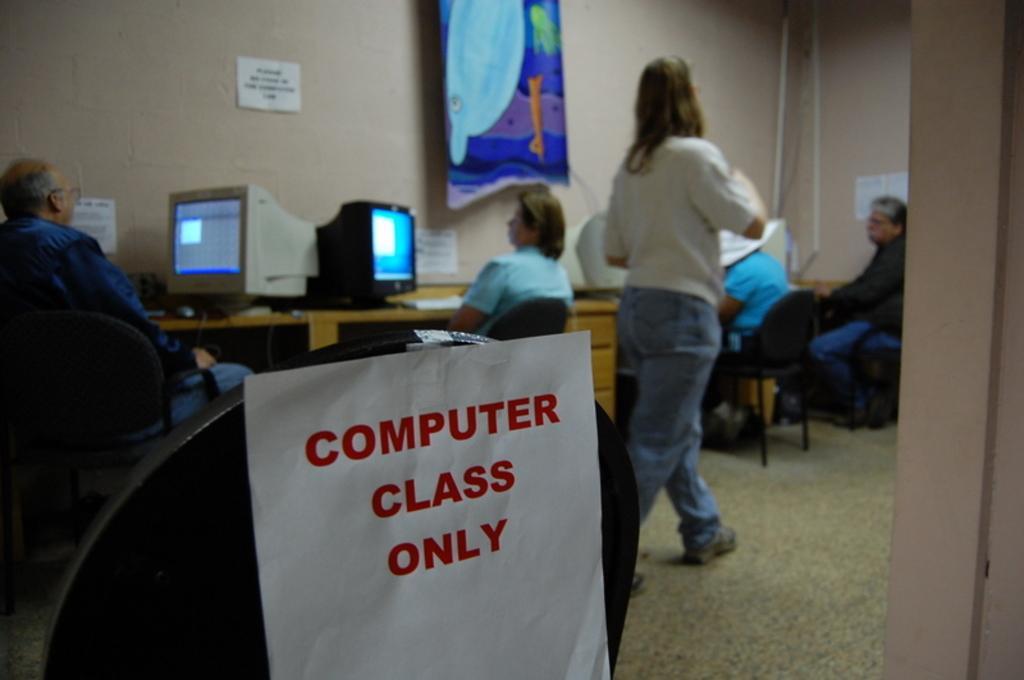In one or two sentences, can you explain what this image depicts? in this picture there are few people sitting on the chairs in front of them there is a table on the table there is a systems keyboard and one woman is walking for once there is a printed paper pasted 